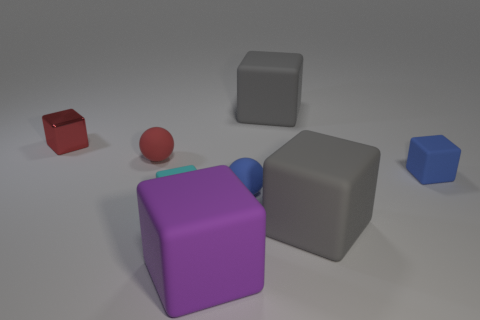Subtract all gray blocks. How many blocks are left? 4 Subtract all cyan cylinders. How many gray cubes are left? 2 Add 1 cubes. How many objects exist? 9 Subtract 1 cubes. How many cubes are left? 5 Subtract all blue cubes. How many cubes are left? 5 Subtract all spheres. How many objects are left? 6 Subtract all green cubes. Subtract all brown cylinders. How many cubes are left? 6 Subtract all gray blocks. Subtract all spheres. How many objects are left? 4 Add 7 small matte cubes. How many small matte cubes are left? 9 Add 2 rubber balls. How many rubber balls exist? 4 